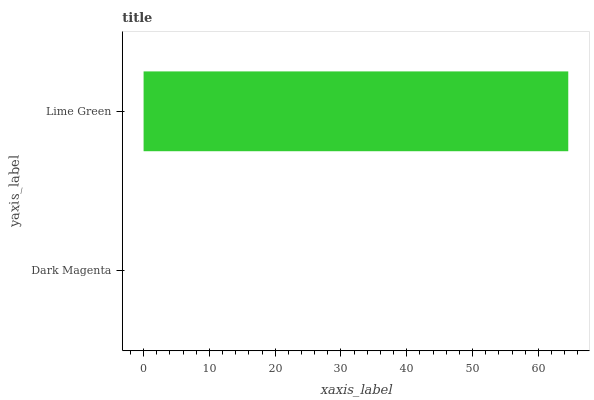Is Dark Magenta the minimum?
Answer yes or no. Yes. Is Lime Green the maximum?
Answer yes or no. Yes. Is Lime Green the minimum?
Answer yes or no. No. Is Lime Green greater than Dark Magenta?
Answer yes or no. Yes. Is Dark Magenta less than Lime Green?
Answer yes or no. Yes. Is Dark Magenta greater than Lime Green?
Answer yes or no. No. Is Lime Green less than Dark Magenta?
Answer yes or no. No. Is Lime Green the high median?
Answer yes or no. Yes. Is Dark Magenta the low median?
Answer yes or no. Yes. Is Dark Magenta the high median?
Answer yes or no. No. Is Lime Green the low median?
Answer yes or no. No. 